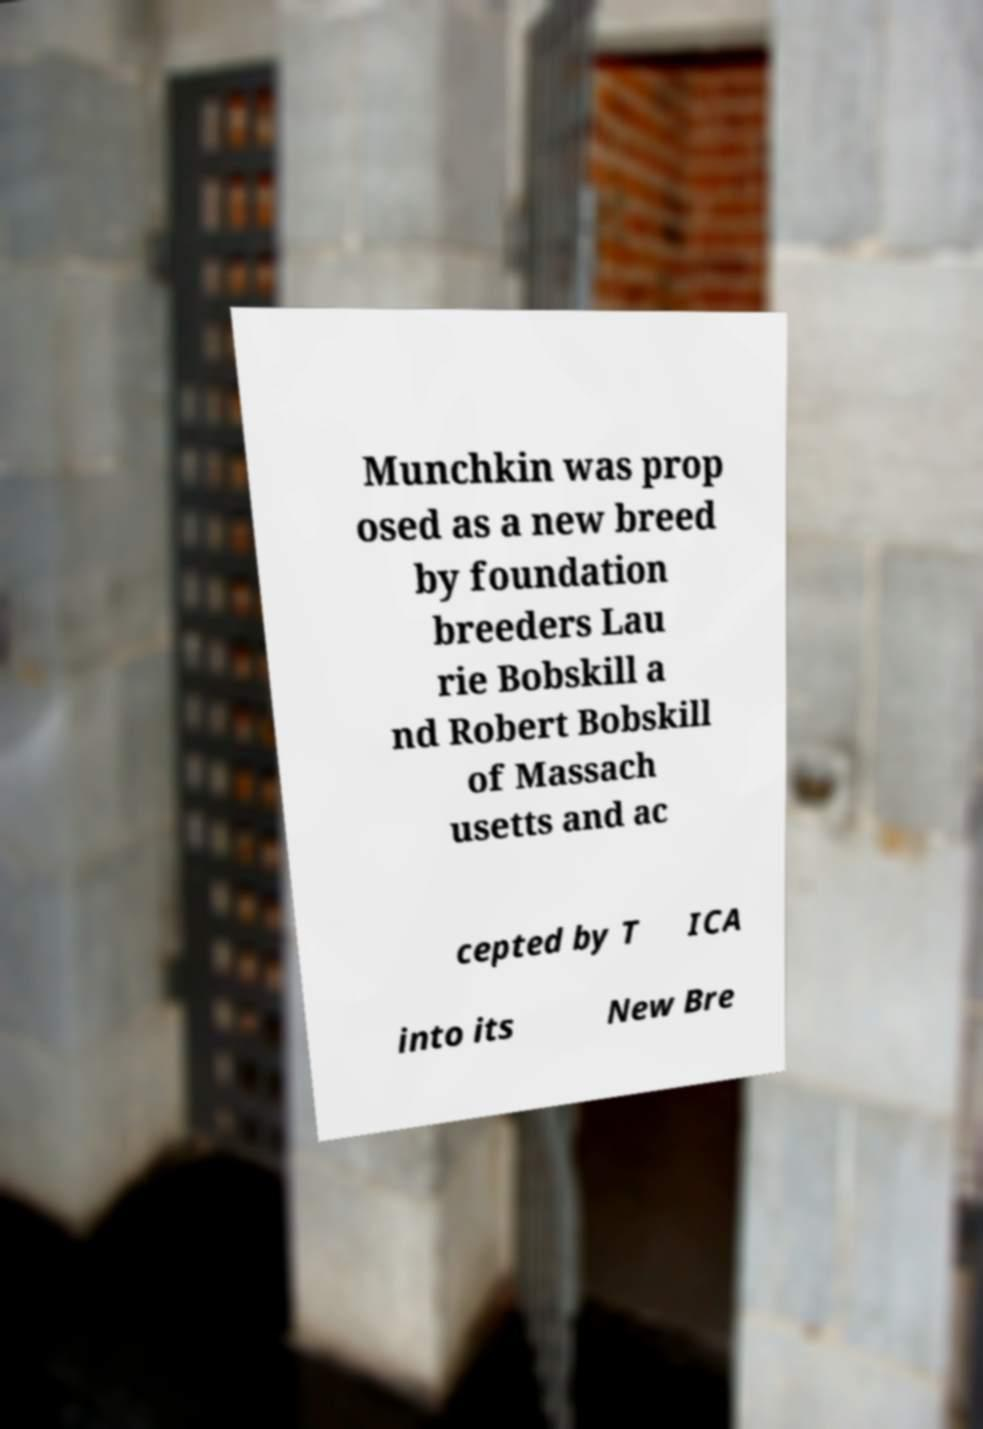Please read and relay the text visible in this image. What does it say? Munchkin was prop osed as a new breed by foundation breeders Lau rie Bobskill a nd Robert Bobskill of Massach usetts and ac cepted by T ICA into its New Bre 